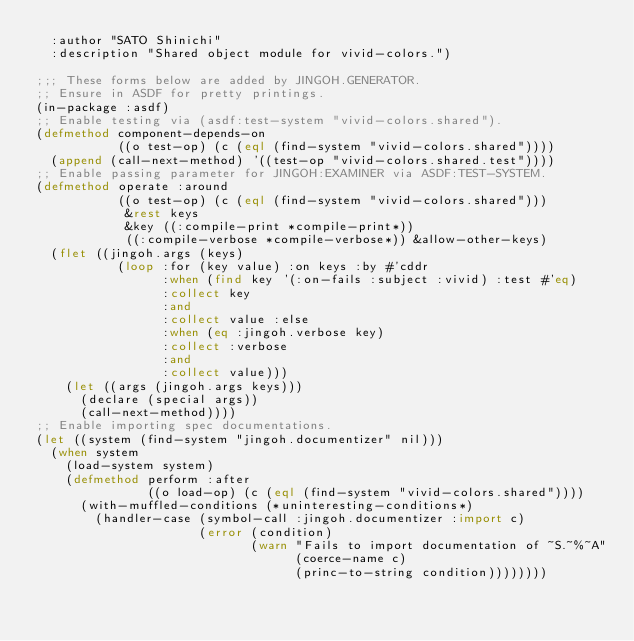<code> <loc_0><loc_0><loc_500><loc_500><_Lisp_>  :author "SATO Shinichi"
  :description "Shared object module for vivid-colors.")

;;; These forms below are added by JINGOH.GENERATOR.
;; Ensure in ASDF for pretty printings.
(in-package :asdf)
;; Enable testing via (asdf:test-system "vivid-colors.shared").
(defmethod component-depends-on
           ((o test-op) (c (eql (find-system "vivid-colors.shared"))))
  (append (call-next-method) '((test-op "vivid-colors.shared.test"))))
;; Enable passing parameter for JINGOH:EXAMINER via ASDF:TEST-SYSTEM.
(defmethod operate :around
           ((o test-op) (c (eql (find-system "vivid-colors.shared")))
            &rest keys
            &key ((:compile-print *compile-print*))
            ((:compile-verbose *compile-verbose*)) &allow-other-keys)
  (flet ((jingoh.args (keys)
           (loop :for (key value) :on keys :by #'cddr
                 :when (find key '(:on-fails :subject :vivid) :test #'eq)
                 :collect key
                 :and
                 :collect value :else
                 :when (eq :jingoh.verbose key)
                 :collect :verbose
                 :and
                 :collect value)))
    (let ((args (jingoh.args keys)))
      (declare (special args))
      (call-next-method))))
;; Enable importing spec documentations.
(let ((system (find-system "jingoh.documentizer" nil)))
  (when system
    (load-system system)
    (defmethod perform :after
               ((o load-op) (c (eql (find-system "vivid-colors.shared"))))
      (with-muffled-conditions (*uninteresting-conditions*)
        (handler-case (symbol-call :jingoh.documentizer :import c)
                      (error (condition)
                             (warn "Fails to import documentation of ~S.~%~A"
                                   (coerce-name c)
                                   (princ-to-string condition))))))))
</code> 